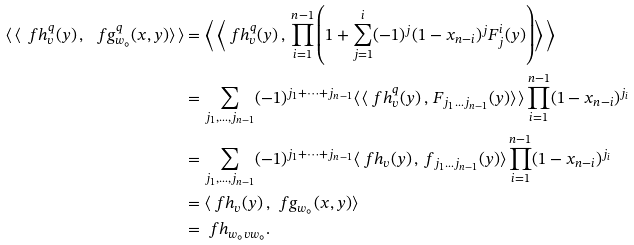<formula> <loc_0><loc_0><loc_500><loc_500>\langle \, \langle \ f h ^ { q } _ { v } ( y ) \, , \, \ f g ^ { q } _ { w _ { \circ } } ( x , y ) \rangle \, \rangle & = \left \langle \, \left \langle \ f h ^ { q } _ { v } ( y ) \, , \, \prod _ { i = 1 } ^ { n - 1 } \left ( 1 + \sum _ { j = 1 } ^ { i } ( - 1 ) ^ { j } ( 1 - x _ { n - i } ) ^ { j } F ^ { i } _ { j } ( y ) \right ) \right \rangle \, \right \rangle \\ & = \sum _ { j _ { 1 } , \dots , j _ { n - 1 } } ( - 1 ) ^ { j _ { 1 } + \dots + j _ { n - 1 } } \langle \, \langle \ f h ^ { q } _ { v } ( y ) \, , \, F _ { j _ { 1 } \dots j _ { n - 1 } } ( y ) \rangle \, \rangle \prod _ { i = 1 } ^ { n - 1 } ( 1 - x _ { n - i } ) ^ { j _ { i } } \\ & = \sum _ { j _ { 1 } , \dots , j _ { n - 1 } } ( - 1 ) ^ { j _ { 1 } + \dots + j _ { n - 1 } } \langle \ f h _ { v } ( y ) \, , \, f _ { j _ { 1 } \dots j _ { n - 1 } } ( y ) \rangle \prod _ { i = 1 } ^ { n - 1 } ( 1 - x _ { n - i } ) ^ { j _ { i } } \\ & = \langle \ f h _ { v } ( y ) \, , \, \ f g _ { w _ { \circ } } ( x , y ) \rangle \\ & = \ f h _ { w _ { \circ } v w _ { \circ } } .</formula> 